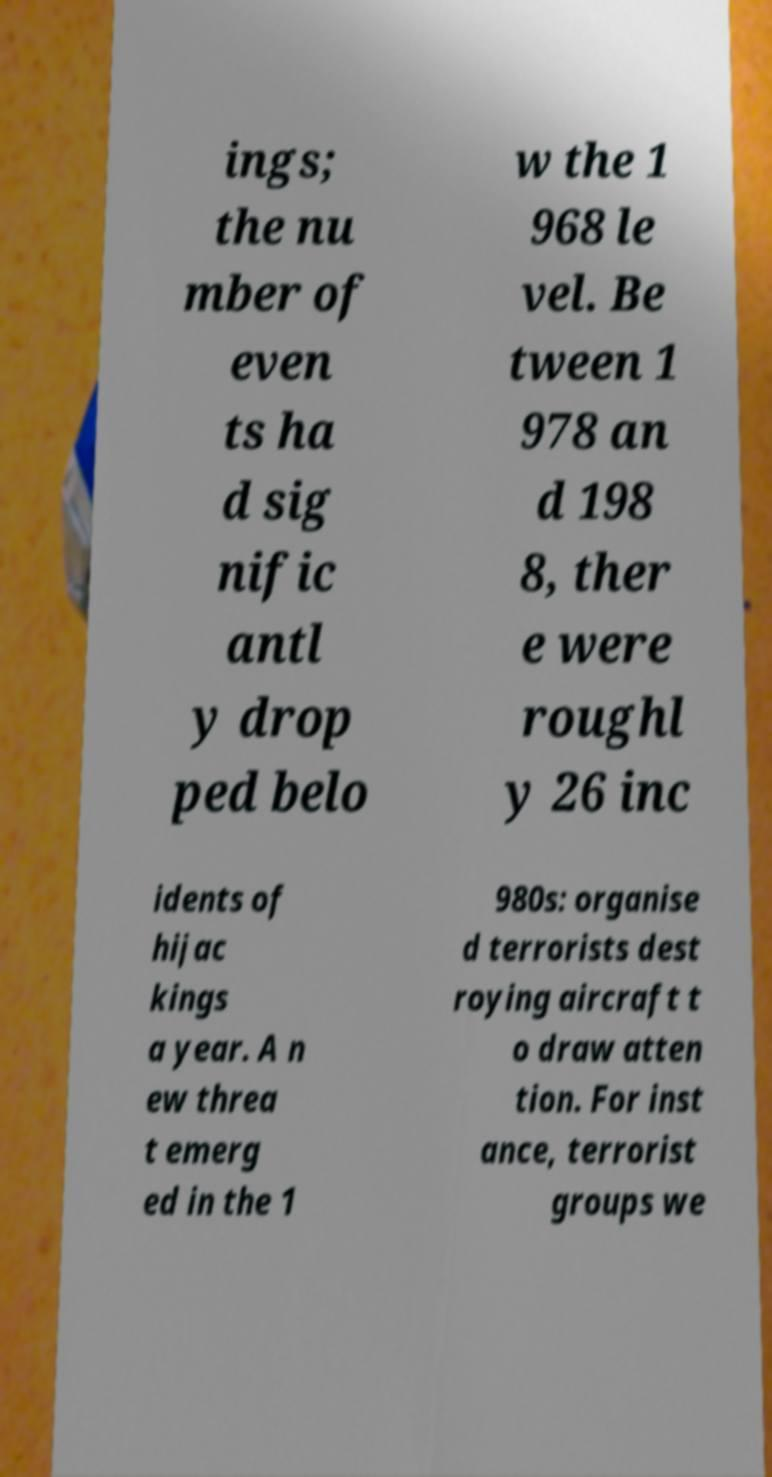There's text embedded in this image that I need extracted. Can you transcribe it verbatim? ings; the nu mber of even ts ha d sig nific antl y drop ped belo w the 1 968 le vel. Be tween 1 978 an d 198 8, ther e were roughl y 26 inc idents of hijac kings a year. A n ew threa t emerg ed in the 1 980s: organise d terrorists dest roying aircraft t o draw atten tion. For inst ance, terrorist groups we 